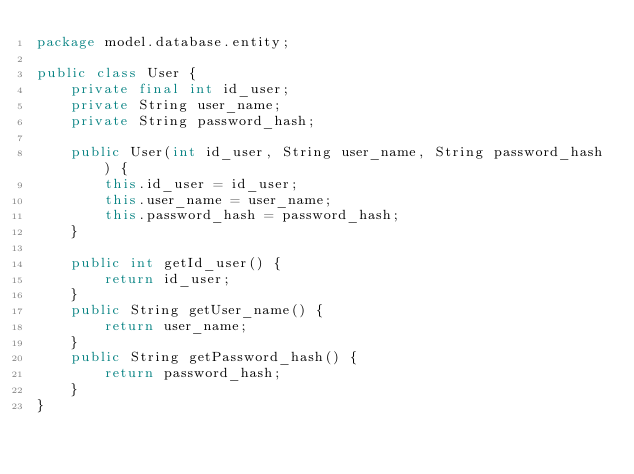Convert code to text. <code><loc_0><loc_0><loc_500><loc_500><_Java_>package model.database.entity;

public class User {
    private final int id_user;
    private String user_name;
    private String password_hash;

    public User(int id_user, String user_name, String password_hash) {
        this.id_user = id_user;
        this.user_name = user_name;
        this.password_hash = password_hash;
    }

    public int getId_user() {
        return id_user;
    }
    public String getUser_name() {
        return user_name;
    }
    public String getPassword_hash() {
        return password_hash;
    }
}
</code> 